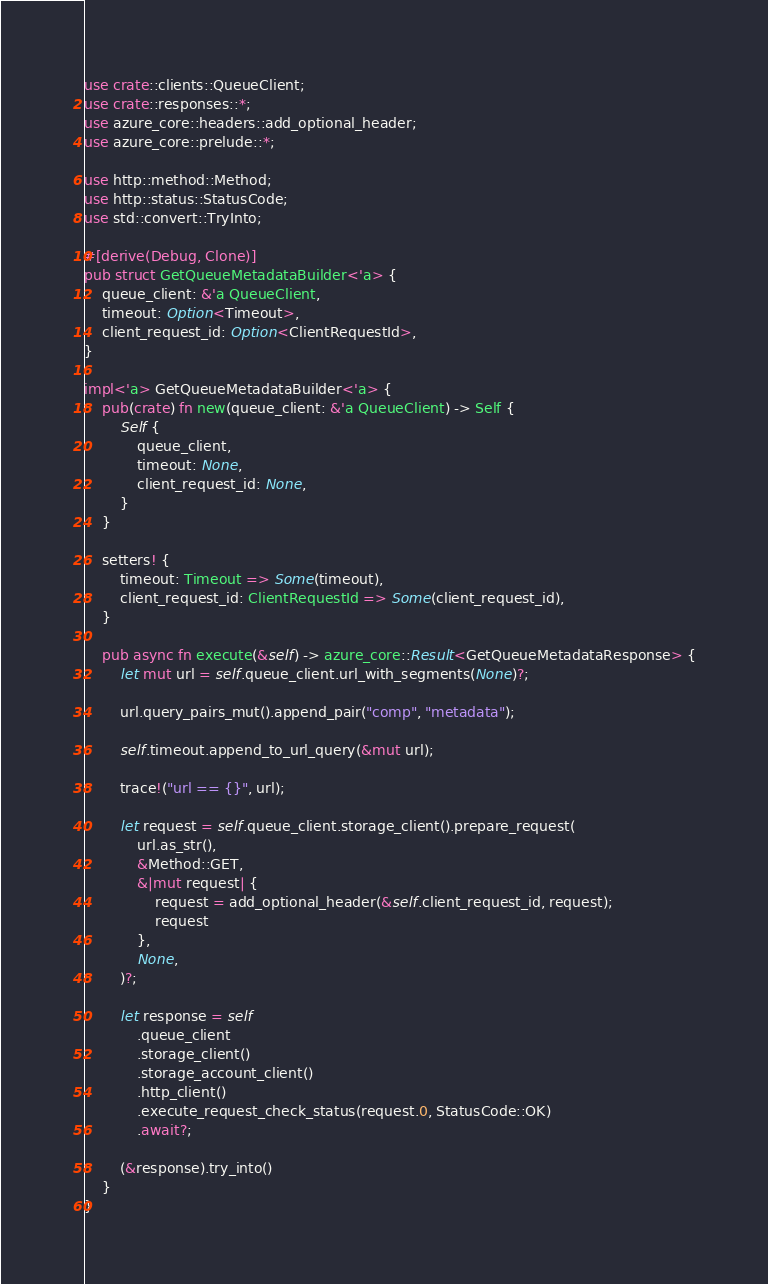<code> <loc_0><loc_0><loc_500><loc_500><_Rust_>use crate::clients::QueueClient;
use crate::responses::*;
use azure_core::headers::add_optional_header;
use azure_core::prelude::*;

use http::method::Method;
use http::status::StatusCode;
use std::convert::TryInto;

#[derive(Debug, Clone)]
pub struct GetQueueMetadataBuilder<'a> {
    queue_client: &'a QueueClient,
    timeout: Option<Timeout>,
    client_request_id: Option<ClientRequestId>,
}

impl<'a> GetQueueMetadataBuilder<'a> {
    pub(crate) fn new(queue_client: &'a QueueClient) -> Self {
        Self {
            queue_client,
            timeout: None,
            client_request_id: None,
        }
    }

    setters! {
        timeout: Timeout => Some(timeout),
        client_request_id: ClientRequestId => Some(client_request_id),
    }

    pub async fn execute(&self) -> azure_core::Result<GetQueueMetadataResponse> {
        let mut url = self.queue_client.url_with_segments(None)?;

        url.query_pairs_mut().append_pair("comp", "metadata");

        self.timeout.append_to_url_query(&mut url);

        trace!("url == {}", url);

        let request = self.queue_client.storage_client().prepare_request(
            url.as_str(),
            &Method::GET,
            &|mut request| {
                request = add_optional_header(&self.client_request_id, request);
                request
            },
            None,
        )?;

        let response = self
            .queue_client
            .storage_client()
            .storage_account_client()
            .http_client()
            .execute_request_check_status(request.0, StatusCode::OK)
            .await?;

        (&response).try_into()
    }
}
</code> 